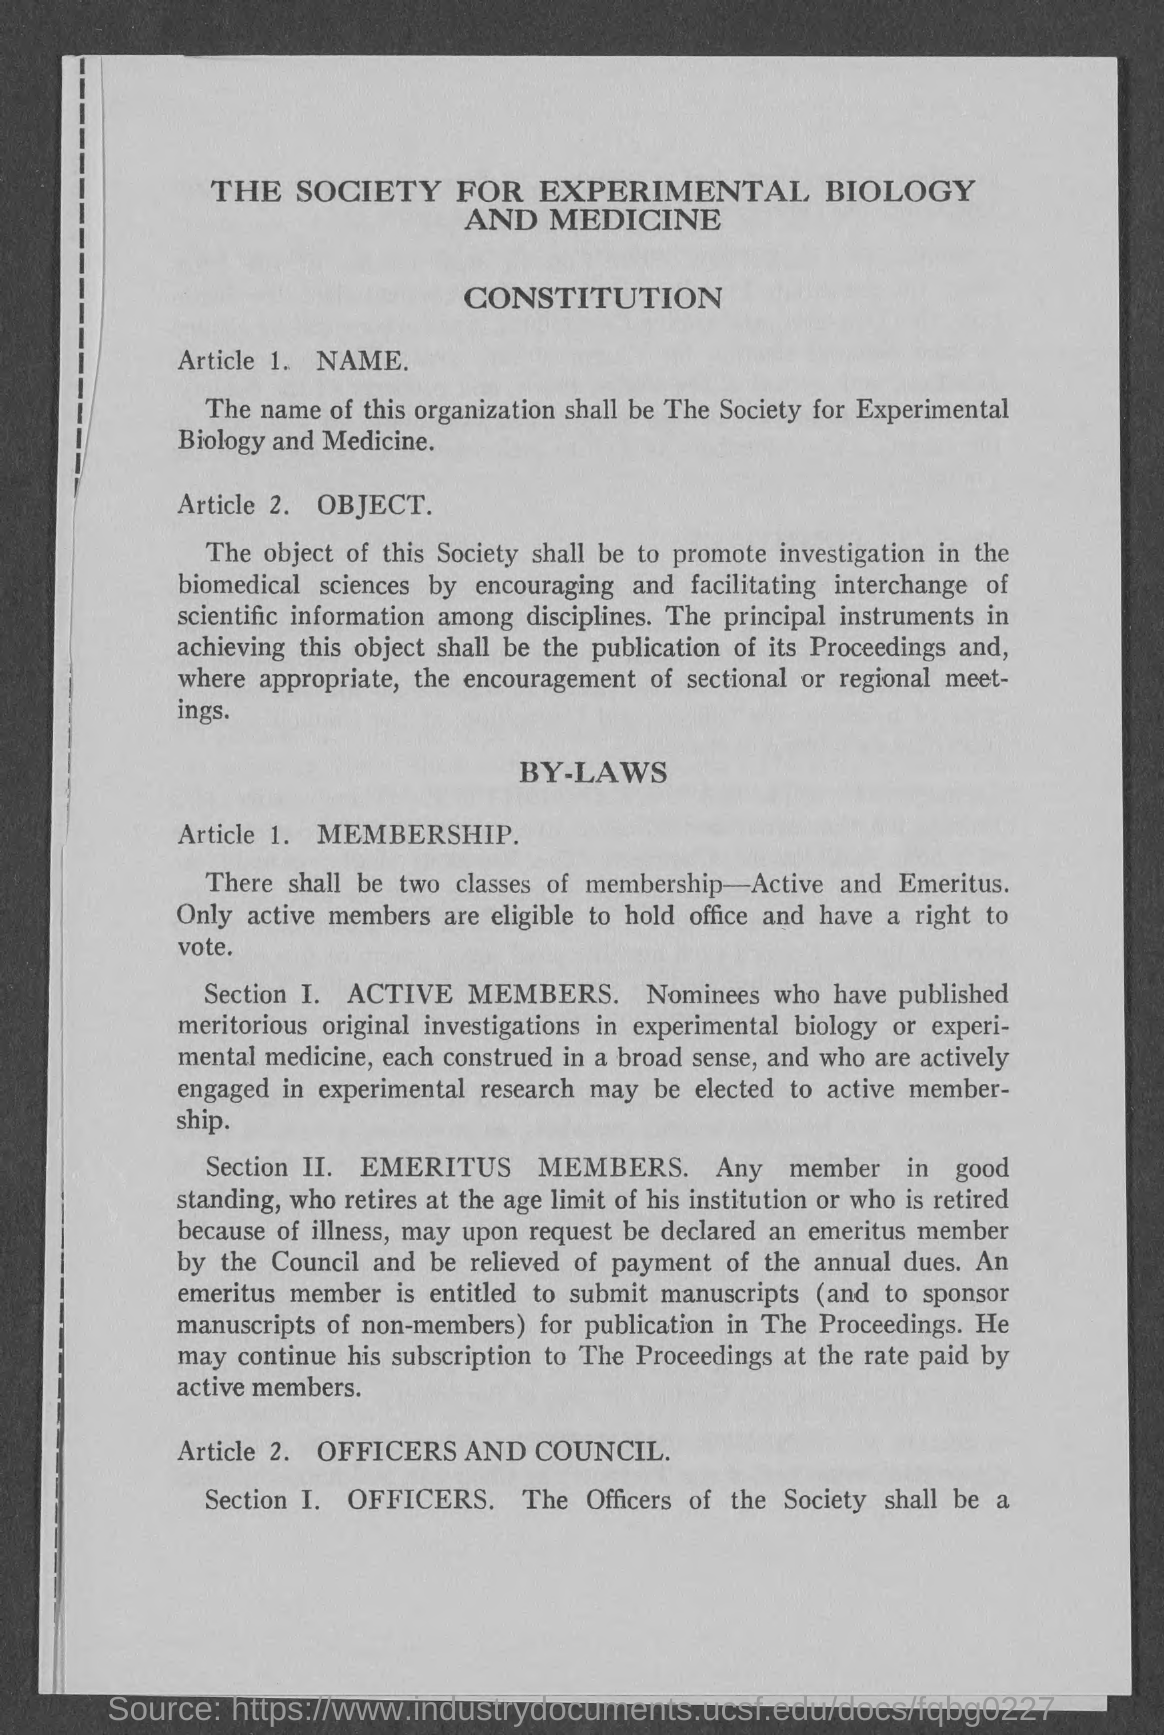Mention a couple of crucial points in this snapshot. The classes of membership at the association are active and emeritus. The Society for Experimental Biology and Medicine is mentioned. Members who are active are eligible to hold office and vote. 